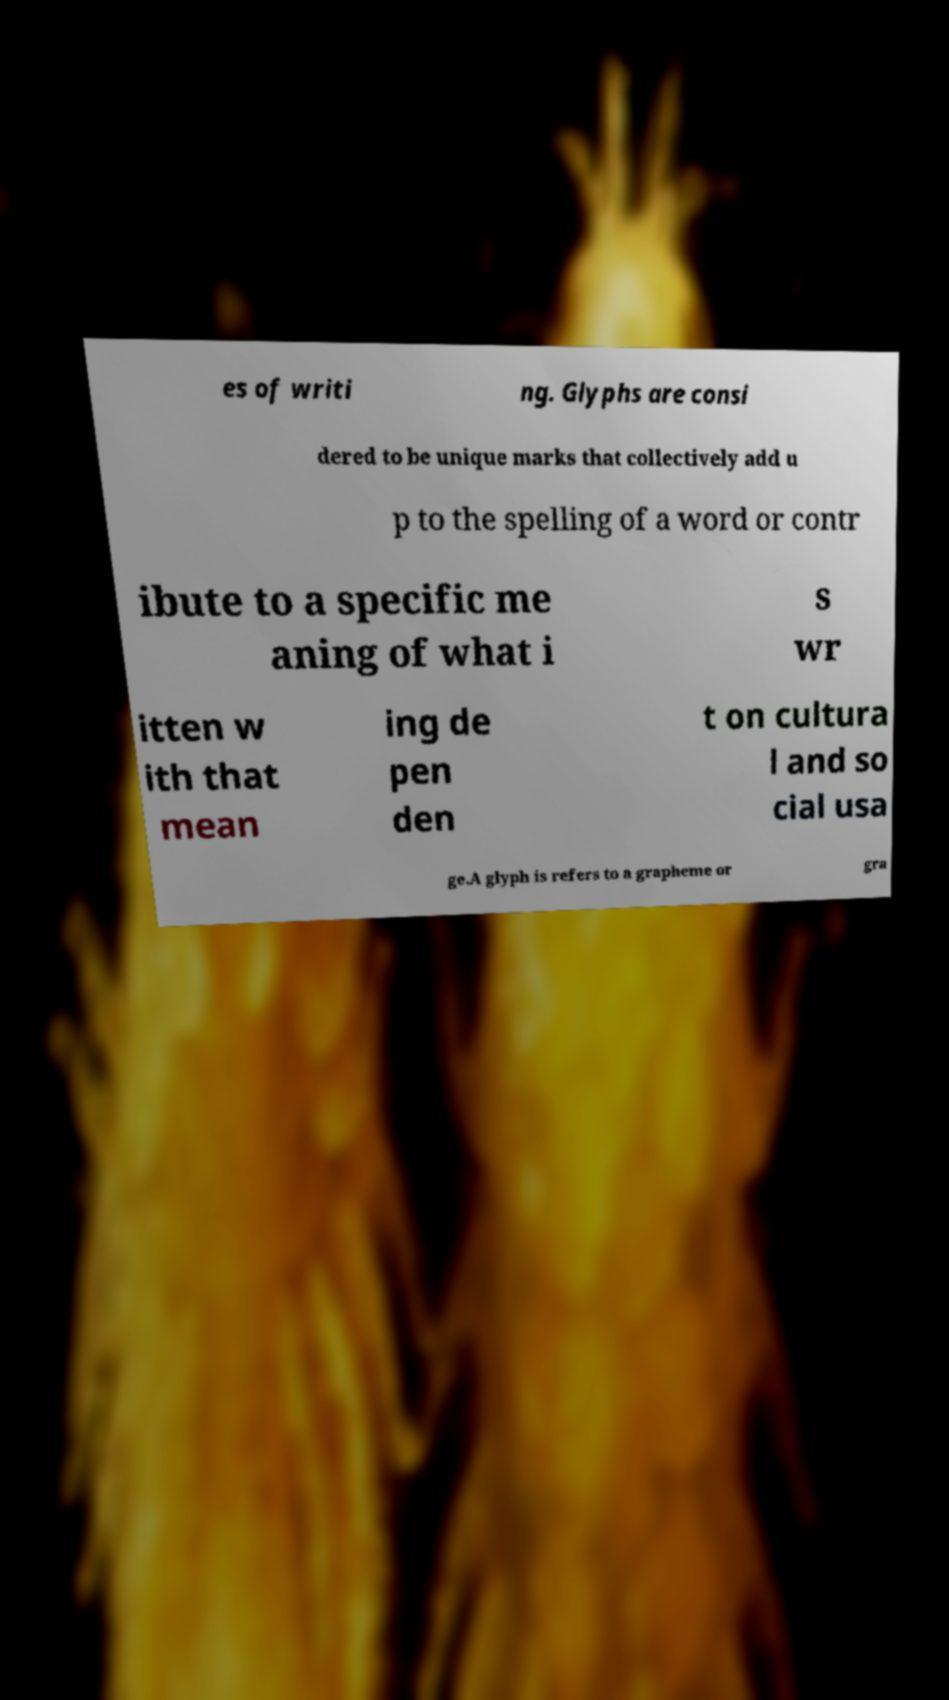For documentation purposes, I need the text within this image transcribed. Could you provide that? es of writi ng. Glyphs are consi dered to be unique marks that collectively add u p to the spelling of a word or contr ibute to a specific me aning of what i s wr itten w ith that mean ing de pen den t on cultura l and so cial usa ge.A glyph is refers to a grapheme or gra 